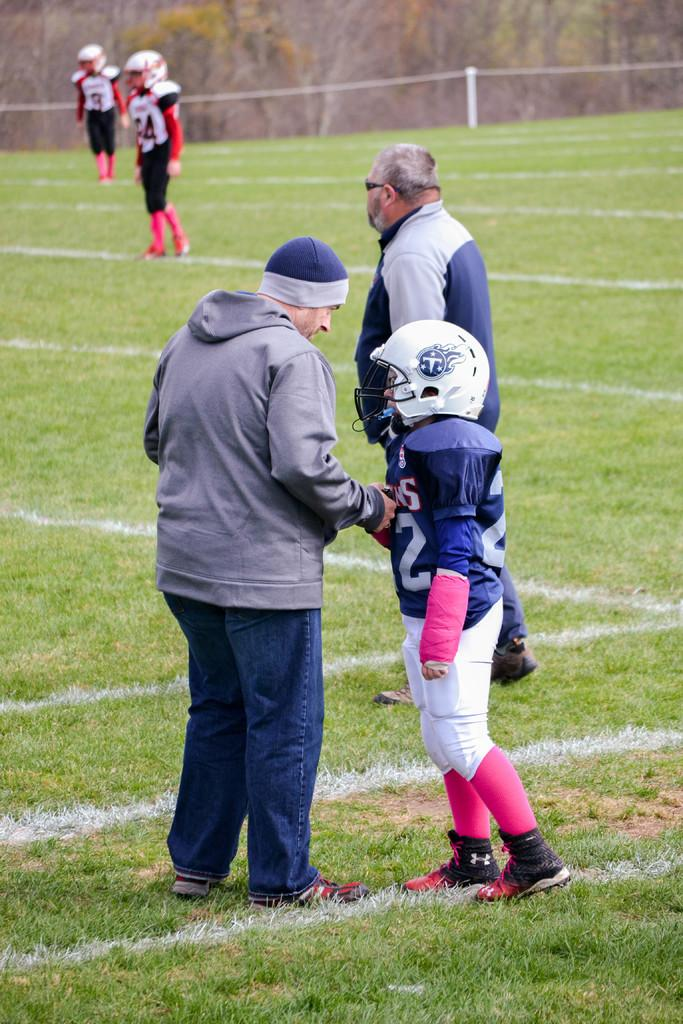How many people are in the image? There are people in the image, but the exact number is not specified. What are some people wearing on their heads? Some people are wearing helmets in the image. Can you describe the headwear of one person? One person is wearing a cap in the image. What type of ground surface is visible in the image? There is grass on the ground in the image. What can be seen in the background of the image? There are trees in the background of the image. What type of table is visible in the image? There is no table present in the image. What is the need for the pickle in the image? There is no pickle present in the image, so it cannot be used for any purpose. 